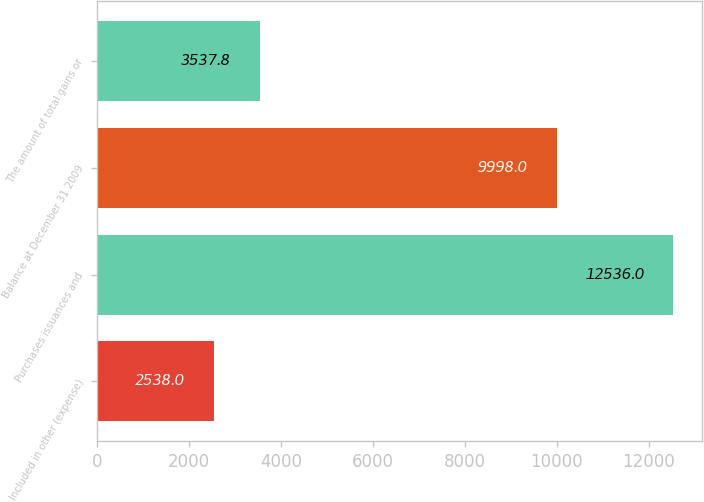Convert chart to OTSL. <chart><loc_0><loc_0><loc_500><loc_500><bar_chart><fcel>Included in other (expense)<fcel>Purchases issuances and<fcel>Balance at December 31 2009<fcel>The amount of total gains or<nl><fcel>2538<fcel>12536<fcel>9998<fcel>3537.8<nl></chart> 